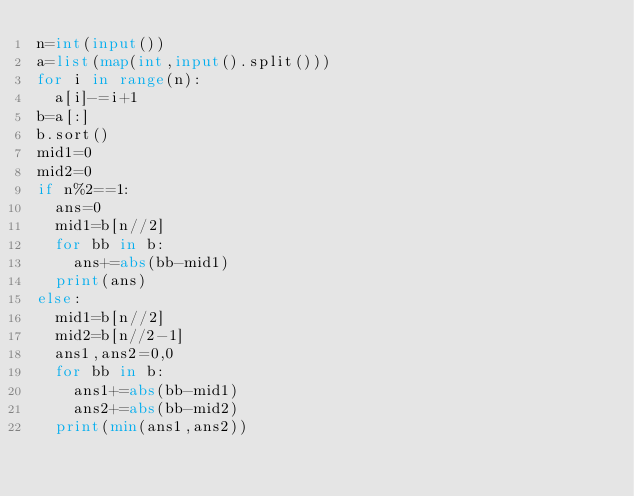<code> <loc_0><loc_0><loc_500><loc_500><_Python_>n=int(input())
a=list(map(int,input().split()))
for i in range(n):
  a[i]-=i+1
b=a[:]
b.sort()
mid1=0
mid2=0
if n%2==1:
  ans=0
  mid1=b[n//2]
  for bb in b:
    ans+=abs(bb-mid1)
  print(ans)
else:
  mid1=b[n//2]
  mid2=b[n//2-1]
  ans1,ans2=0,0
  for bb in b:
    ans1+=abs(bb-mid1)
    ans2+=abs(bb-mid2)
  print(min(ans1,ans2))
</code> 